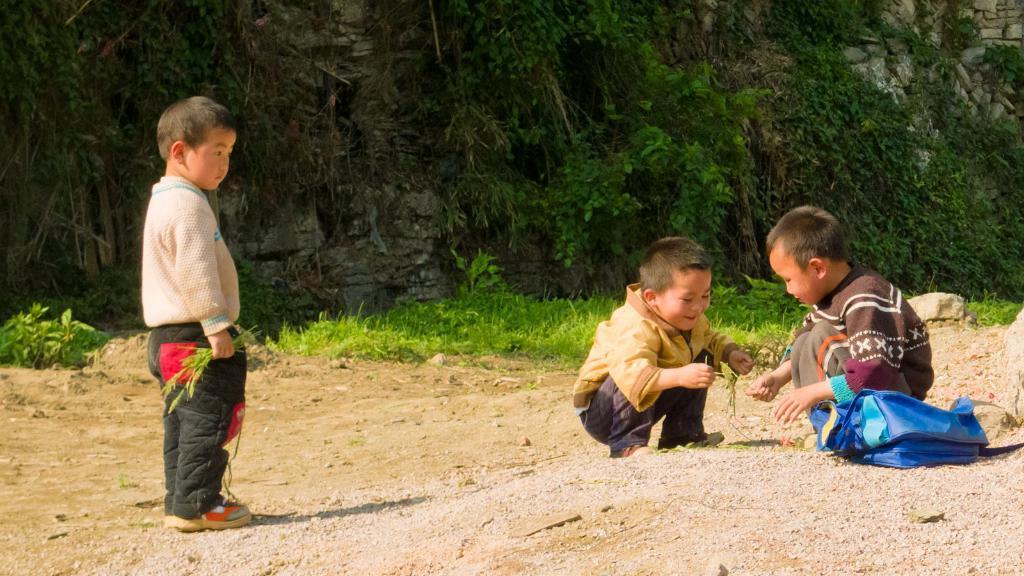How would you summarize this image in a sentence or two? On the right side there are two boys sitting on the ground and smiling. Beside these boys there is a blue color bag. On the left side another boy is standing and looking at these boys. In the background there is grass on the ground and also I can see a rock. 